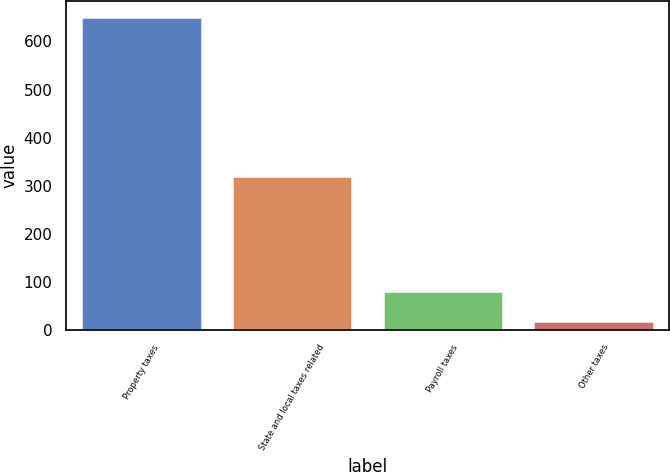Convert chart to OTSL. <chart><loc_0><loc_0><loc_500><loc_500><bar_chart><fcel>Property taxes<fcel>State and local taxes related<fcel>Payroll taxes<fcel>Other taxes<nl><fcel>651<fcel>321<fcel>81.3<fcel>18<nl></chart> 